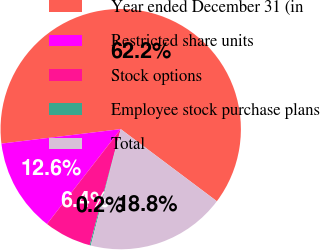Convert chart to OTSL. <chart><loc_0><loc_0><loc_500><loc_500><pie_chart><fcel>Year ended December 31 (in<fcel>Restricted share units<fcel>Stock options<fcel>Employee stock purchase plans<fcel>Total<nl><fcel>62.17%<fcel>12.56%<fcel>6.36%<fcel>0.15%<fcel>18.76%<nl></chart> 